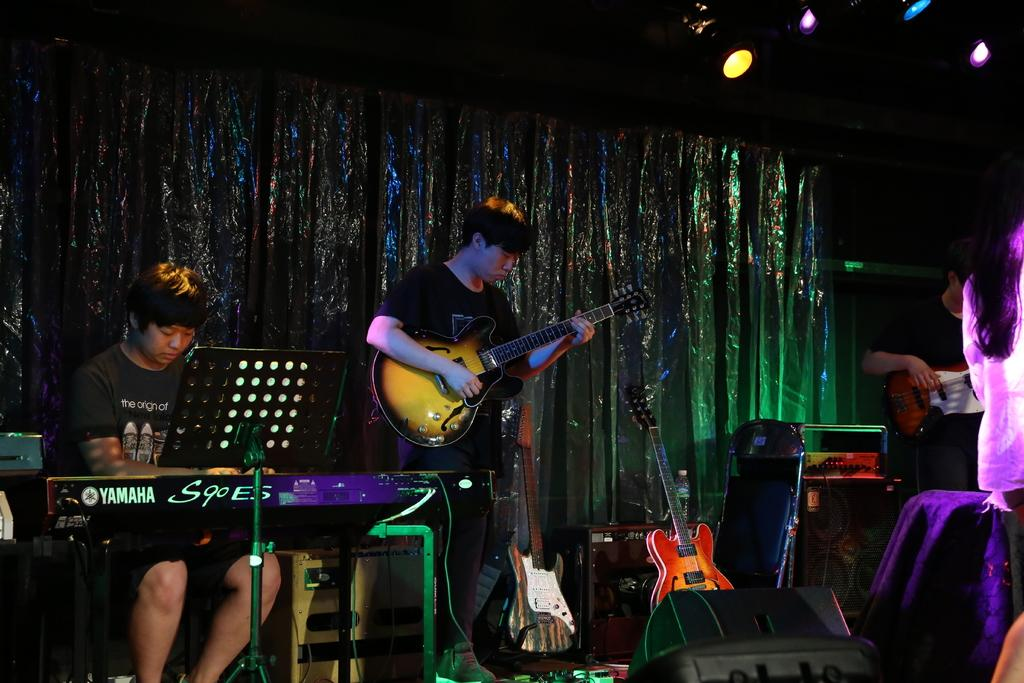What is happening on the stage in the image? There are people on the stage, and they are performing. What type of performance is taking place? The performance involves playing musical instruments. What can be seen behind the performers on the stage? There are musical instruments and a curtain behind the performers. Can you describe the lighting in the image? There is lighting present in the image. Where is the pet sitting in the garden in the image? There is no pet or garden present in the image; it features people performing on a stage. 